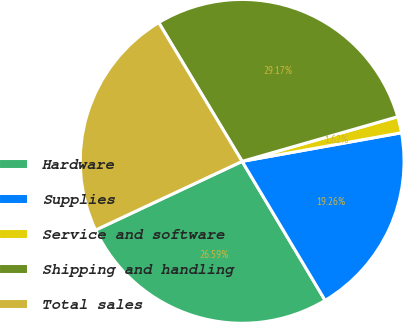Convert chart to OTSL. <chart><loc_0><loc_0><loc_500><loc_500><pie_chart><fcel>Hardware<fcel>Supplies<fcel>Service and software<fcel>Shipping and handling<fcel>Total sales<nl><fcel>26.59%<fcel>19.26%<fcel>1.62%<fcel>29.17%<fcel>23.36%<nl></chart> 